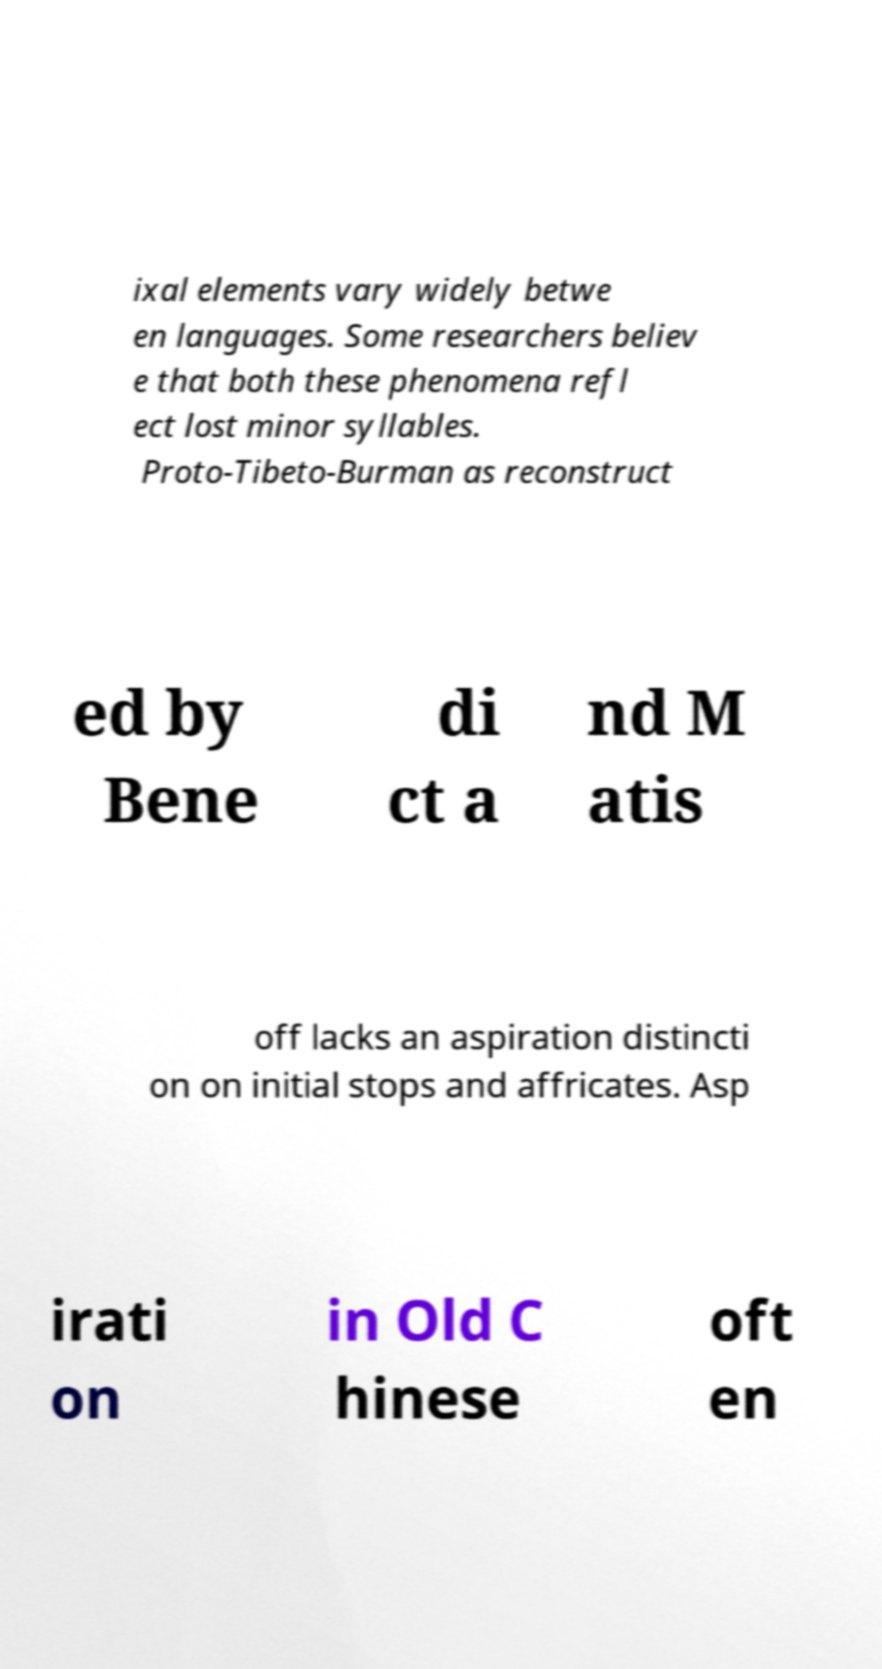There's text embedded in this image that I need extracted. Can you transcribe it verbatim? ixal elements vary widely betwe en languages. Some researchers believ e that both these phenomena refl ect lost minor syllables. Proto-Tibeto-Burman as reconstruct ed by Bene di ct a nd M atis off lacks an aspiration distincti on on initial stops and affricates. Asp irati on in Old C hinese oft en 